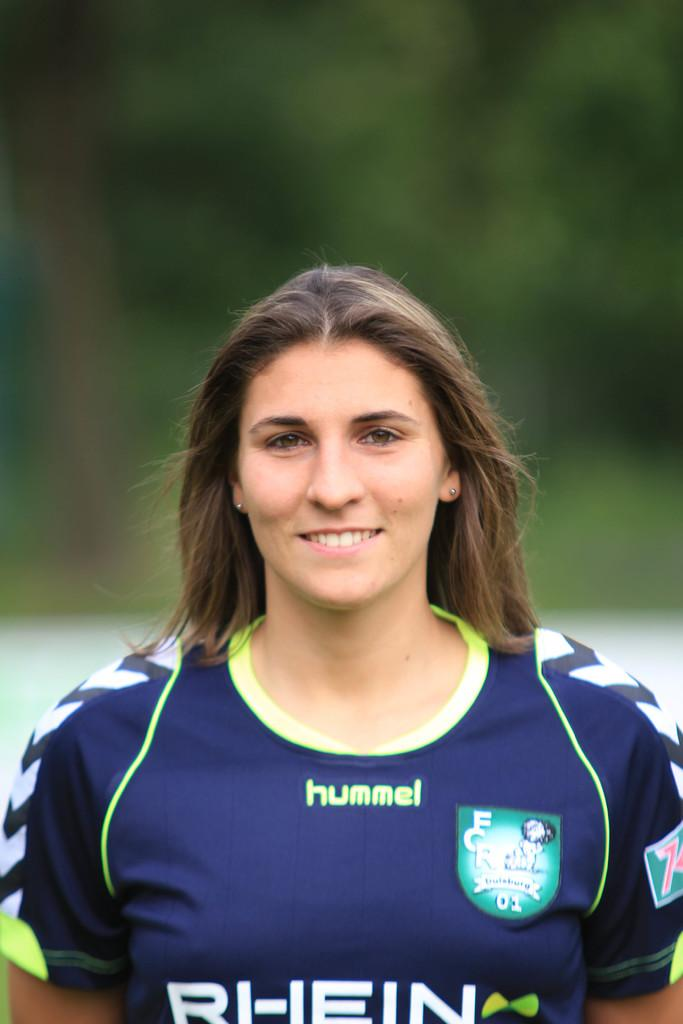<image>
Summarize the visual content of the image. a female wearing a blue shirt sponsored by hummel 